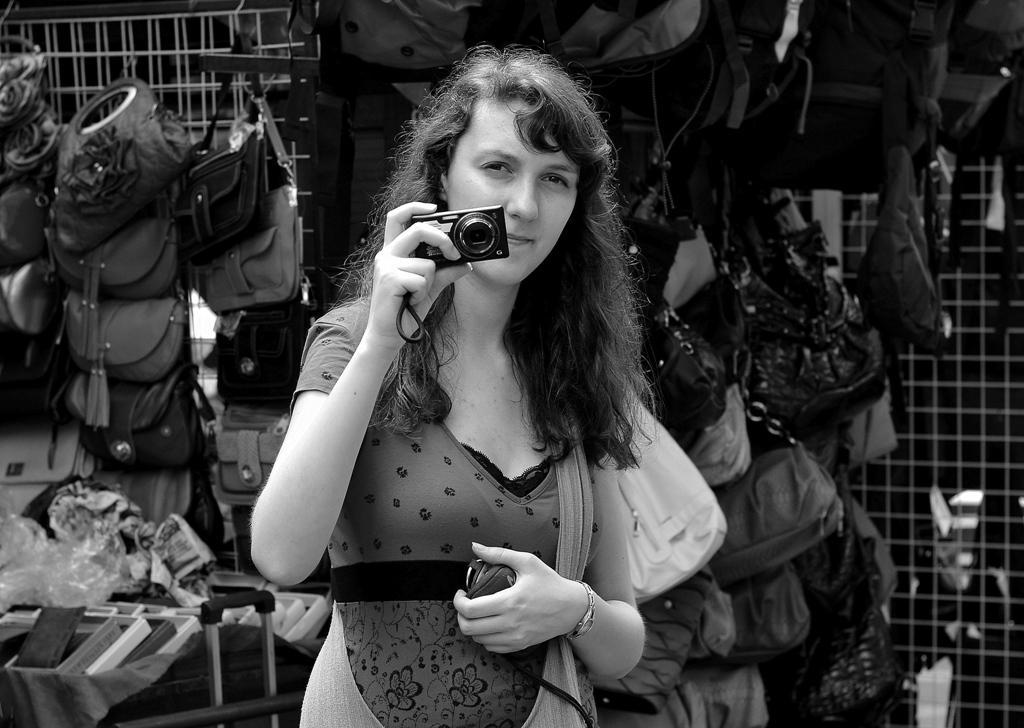Please provide a concise description of this image. The lady is holding a camera in her right hand and there are group of hand bags in the background attached to the fence. 